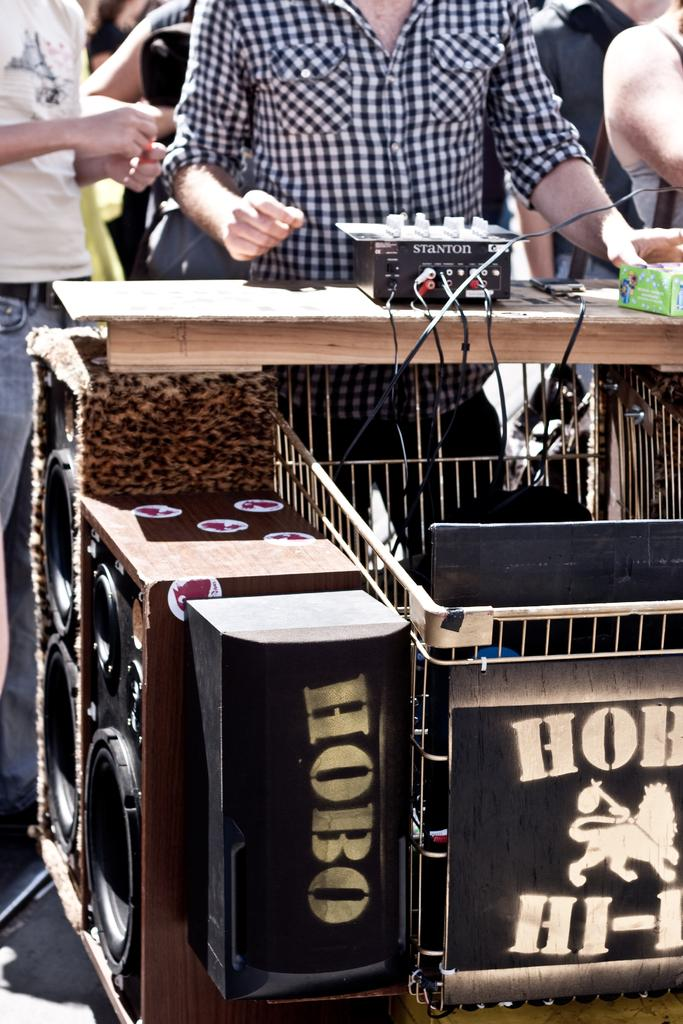What is the main subject of the image? The main subject of the image is a man standing. What is the man wearing in the image? The man is wearing a black and white checked shirt. What objects can be seen in the image besides the man? There are speakers visible in the image. Can you see any robins or snails in the image? No, there are no robins or snails present in the image. Is the man standing in a zoo in the image? There is no information provided about the location or setting of the image, so it cannot be determined if the man is standing in a zoo. 